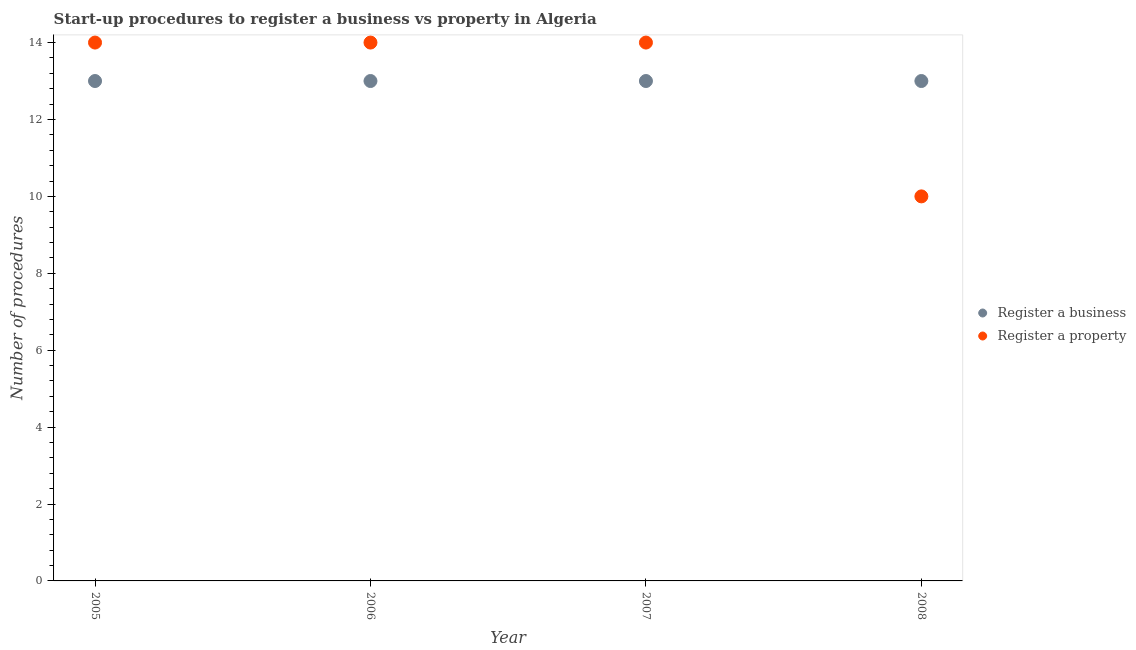How many different coloured dotlines are there?
Offer a very short reply. 2. Is the number of dotlines equal to the number of legend labels?
Ensure brevity in your answer.  Yes. What is the number of procedures to register a property in 2007?
Ensure brevity in your answer.  14. Across all years, what is the maximum number of procedures to register a property?
Give a very brief answer. 14. Across all years, what is the minimum number of procedures to register a business?
Offer a very short reply. 13. In which year was the number of procedures to register a business maximum?
Offer a terse response. 2005. In which year was the number of procedures to register a property minimum?
Give a very brief answer. 2008. What is the total number of procedures to register a property in the graph?
Provide a succinct answer. 52. What is the difference between the number of procedures to register a business in 2005 and that in 2007?
Offer a very short reply. 0. What is the difference between the number of procedures to register a business in 2007 and the number of procedures to register a property in 2006?
Your response must be concise. -1. What is the average number of procedures to register a business per year?
Provide a succinct answer. 13. In the year 2008, what is the difference between the number of procedures to register a property and number of procedures to register a business?
Keep it short and to the point. -3. In how many years, is the number of procedures to register a business greater than 11.6?
Offer a very short reply. 4. What is the ratio of the number of procedures to register a property in 2005 to that in 2007?
Keep it short and to the point. 1. Is the number of procedures to register a property in 2006 less than that in 2007?
Your response must be concise. No. What is the difference between the highest and the second highest number of procedures to register a business?
Ensure brevity in your answer.  0. What is the difference between the highest and the lowest number of procedures to register a property?
Keep it short and to the point. 4. In how many years, is the number of procedures to register a business greater than the average number of procedures to register a business taken over all years?
Provide a short and direct response. 0. Is the sum of the number of procedures to register a property in 2005 and 2006 greater than the maximum number of procedures to register a business across all years?
Keep it short and to the point. Yes. Does the number of procedures to register a property monotonically increase over the years?
Your answer should be compact. No. How many dotlines are there?
Make the answer very short. 2. Are the values on the major ticks of Y-axis written in scientific E-notation?
Give a very brief answer. No. Does the graph contain grids?
Give a very brief answer. No. Where does the legend appear in the graph?
Provide a succinct answer. Center right. How many legend labels are there?
Offer a terse response. 2. How are the legend labels stacked?
Make the answer very short. Vertical. What is the title of the graph?
Keep it short and to the point. Start-up procedures to register a business vs property in Algeria. What is the label or title of the X-axis?
Keep it short and to the point. Year. What is the label or title of the Y-axis?
Provide a short and direct response. Number of procedures. What is the Number of procedures in Register a business in 2005?
Your response must be concise. 13. What is the Number of procedures of Register a property in 2005?
Provide a succinct answer. 14. What is the Number of procedures of Register a business in 2006?
Keep it short and to the point. 13. What is the Number of procedures in Register a business in 2007?
Make the answer very short. 13. What is the Number of procedures in Register a business in 2008?
Your answer should be compact. 13. Across all years, what is the maximum Number of procedures of Register a business?
Your answer should be very brief. 13. Across all years, what is the maximum Number of procedures of Register a property?
Your answer should be compact. 14. What is the total Number of procedures of Register a business in the graph?
Offer a very short reply. 52. What is the difference between the Number of procedures of Register a business in 2005 and that in 2008?
Offer a very short reply. 0. What is the difference between the Number of procedures of Register a property in 2005 and that in 2008?
Provide a short and direct response. 4. What is the difference between the Number of procedures in Register a business in 2006 and that in 2007?
Your answer should be very brief. 0. What is the difference between the Number of procedures in Register a property in 2006 and that in 2007?
Give a very brief answer. 0. What is the difference between the Number of procedures in Register a property in 2006 and that in 2008?
Give a very brief answer. 4. What is the difference between the Number of procedures of Register a business in 2007 and that in 2008?
Give a very brief answer. 0. What is the difference between the Number of procedures of Register a business in 2006 and the Number of procedures of Register a property in 2007?
Your response must be concise. -1. What is the average Number of procedures in Register a business per year?
Your answer should be compact. 13. In the year 2006, what is the difference between the Number of procedures in Register a business and Number of procedures in Register a property?
Give a very brief answer. -1. In the year 2008, what is the difference between the Number of procedures of Register a business and Number of procedures of Register a property?
Keep it short and to the point. 3. What is the ratio of the Number of procedures in Register a property in 2005 to that in 2006?
Provide a succinct answer. 1. What is the ratio of the Number of procedures of Register a business in 2005 to that in 2007?
Offer a terse response. 1. What is the ratio of the Number of procedures in Register a business in 2005 to that in 2008?
Make the answer very short. 1. What is the ratio of the Number of procedures of Register a business in 2007 to that in 2008?
Provide a short and direct response. 1. What is the difference between the highest and the second highest Number of procedures of Register a property?
Offer a very short reply. 0. What is the difference between the highest and the lowest Number of procedures of Register a business?
Offer a terse response. 0. 